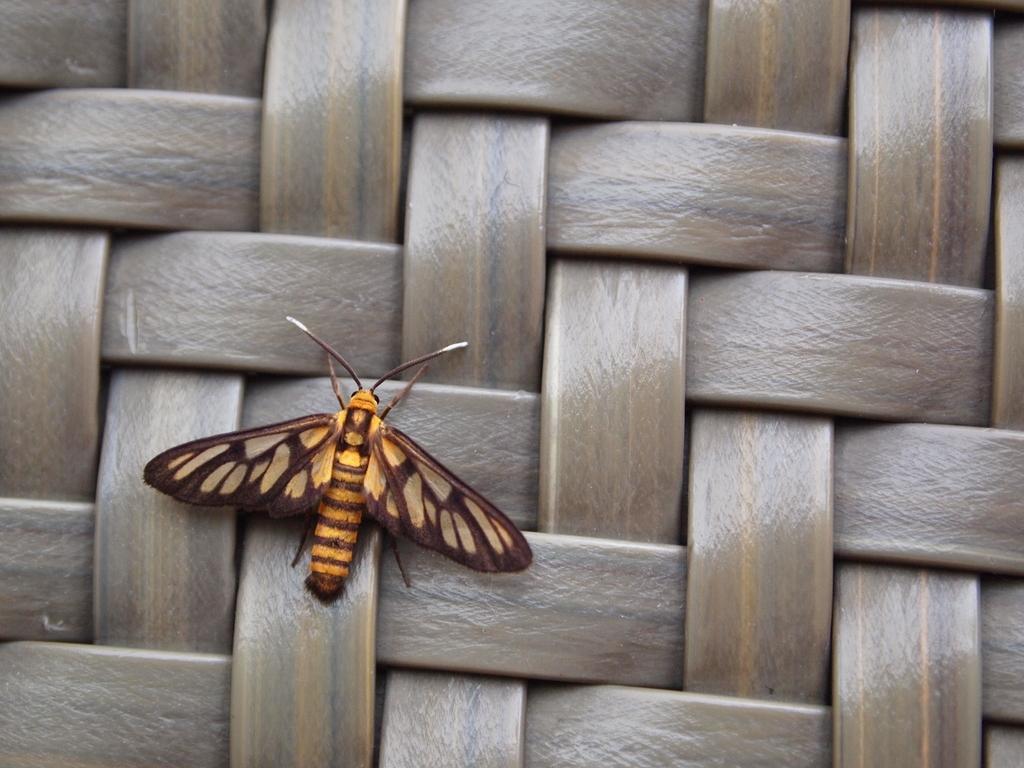Please provide a concise description of this image. In this picture, we see an insect in brown and yellow color. In the background, it is in brown color and it might be a cat with the nylon strips. 